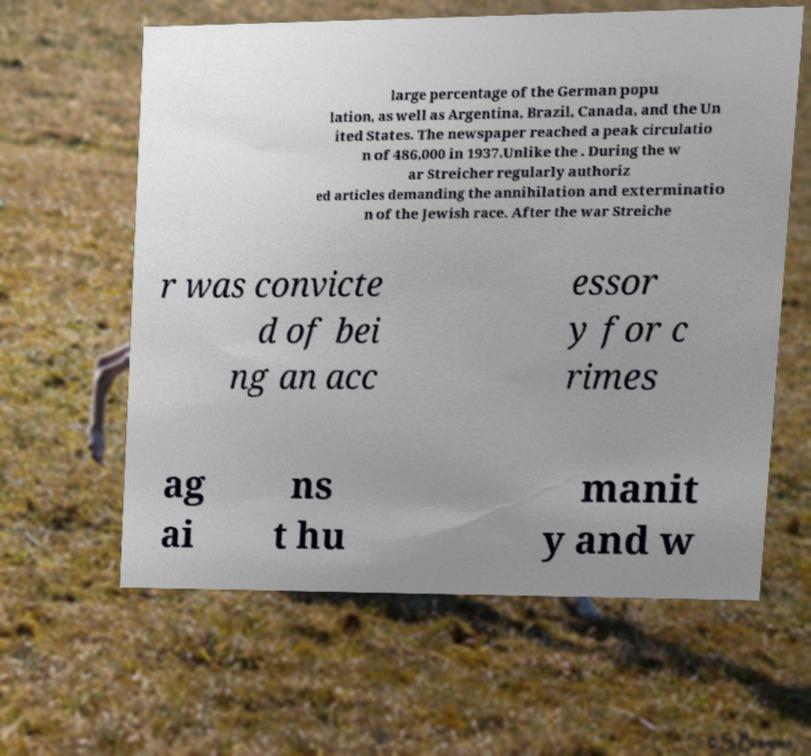For documentation purposes, I need the text within this image transcribed. Could you provide that? large percentage of the German popu lation, as well as Argentina, Brazil, Canada, and the Un ited States. The newspaper reached a peak circulatio n of 486,000 in 1937.Unlike the . During the w ar Streicher regularly authoriz ed articles demanding the annihilation and exterminatio n of the Jewish race. After the war Streiche r was convicte d of bei ng an acc essor y for c rimes ag ai ns t hu manit y and w 